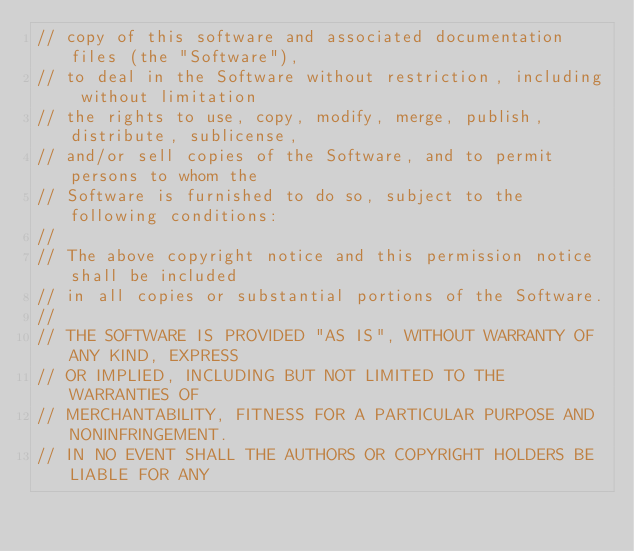<code> <loc_0><loc_0><loc_500><loc_500><_C++_>// copy of this software and associated documentation files (the "Software"),
// to deal in the Software without restriction, including without limitation
// the rights to use, copy, modify, merge, publish, distribute, sublicense,
// and/or sell copies of the Software, and to permit persons to whom the
// Software is furnished to do so, subject to the following conditions:
//
// The above copyright notice and this permission notice shall be included
// in all copies or substantial portions of the Software.
//
// THE SOFTWARE IS PROVIDED "AS IS", WITHOUT WARRANTY OF ANY KIND, EXPRESS
// OR IMPLIED, INCLUDING BUT NOT LIMITED TO THE WARRANTIES OF
// MERCHANTABILITY, FITNESS FOR A PARTICULAR PURPOSE AND NONINFRINGEMENT.
// IN NO EVENT SHALL THE AUTHORS OR COPYRIGHT HOLDERS BE LIABLE FOR ANY</code> 